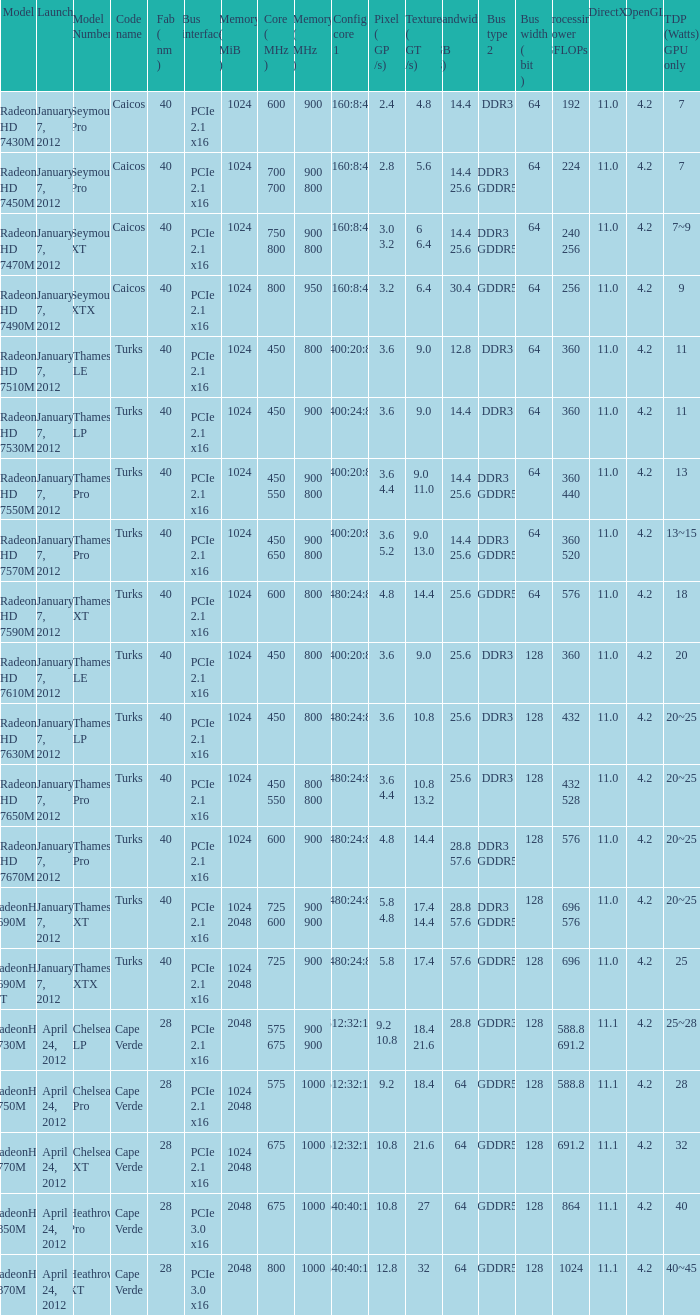What is the configuration of the core 1 in a model that has a processing capability of 432 gflops? 480:24:8. 